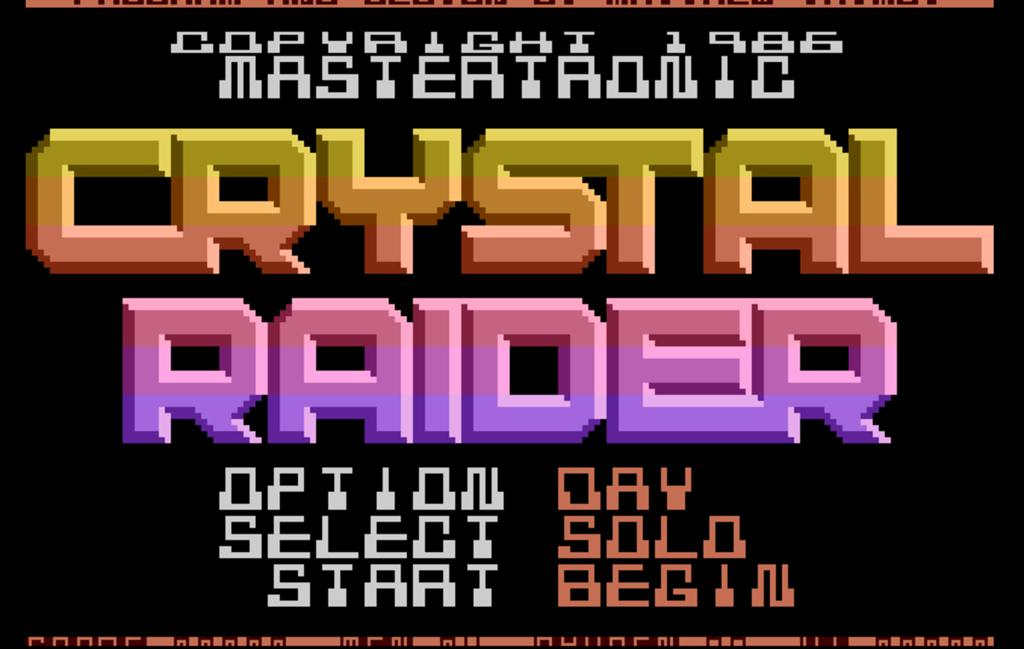<image>
Create a compact narrative representing the image presented. A menu page for a game called Crystal Raider. 